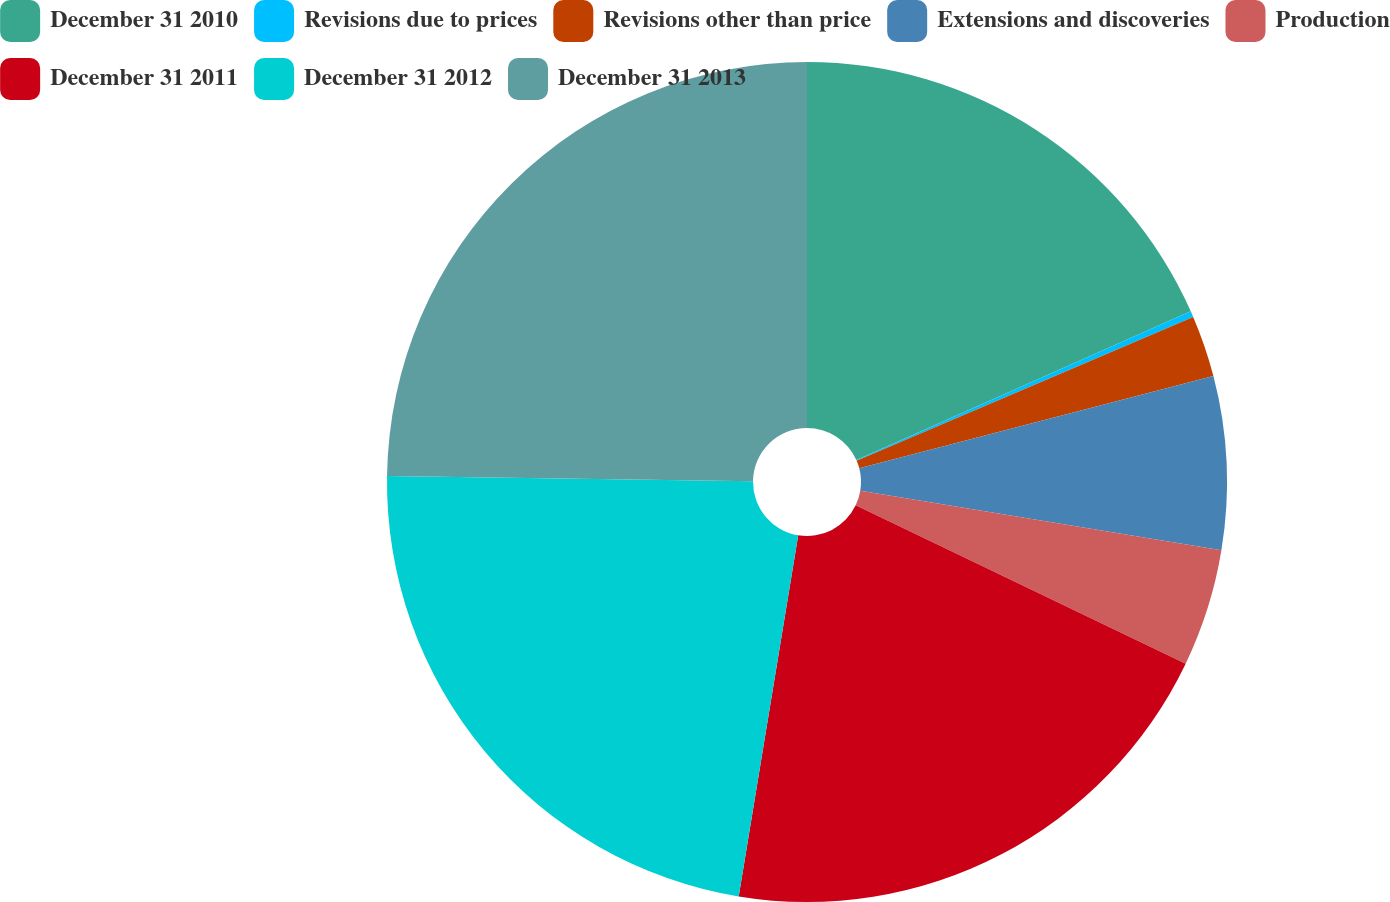<chart> <loc_0><loc_0><loc_500><loc_500><pie_chart><fcel>December 31 2010<fcel>Revisions due to prices<fcel>Revisions other than price<fcel>Extensions and discoveries<fcel>Production<fcel>December 31 2011<fcel>December 31 2012<fcel>December 31 2013<nl><fcel>18.34%<fcel>0.23%<fcel>2.37%<fcel>6.66%<fcel>4.52%<fcel>20.48%<fcel>22.63%<fcel>24.77%<nl></chart> 